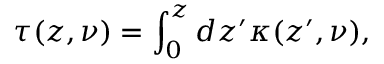Convert formula to latex. <formula><loc_0><loc_0><loc_500><loc_500>\tau ( z , \nu ) = \int _ { 0 } ^ { z } d z ^ { \prime } \kappa ( z ^ { \prime } , \nu ) ,</formula> 